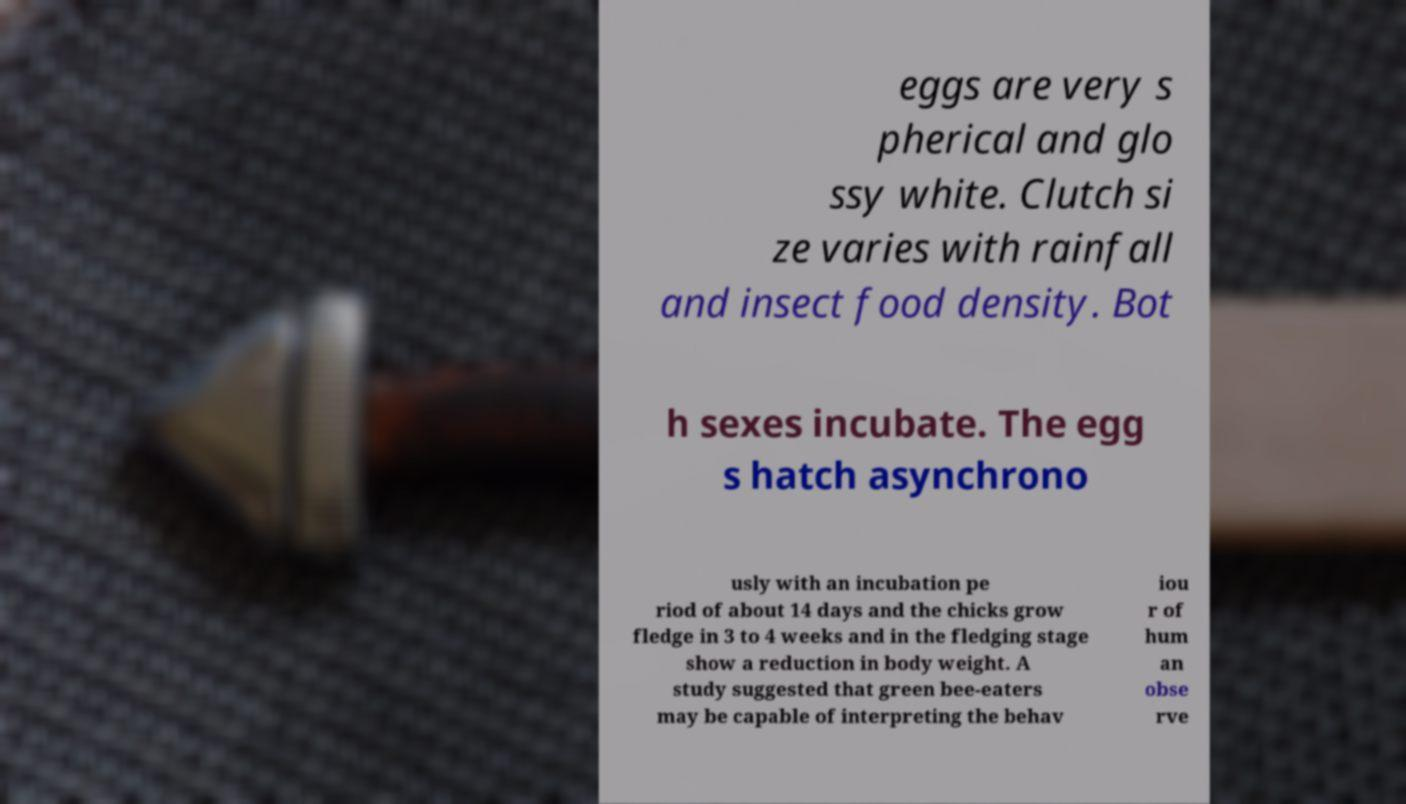There's text embedded in this image that I need extracted. Can you transcribe it verbatim? eggs are very s pherical and glo ssy white. Clutch si ze varies with rainfall and insect food density. Bot h sexes incubate. The egg s hatch asynchrono usly with an incubation pe riod of about 14 days and the chicks grow fledge in 3 to 4 weeks and in the fledging stage show a reduction in body weight. A study suggested that green bee-eaters may be capable of interpreting the behav iou r of hum an obse rve 